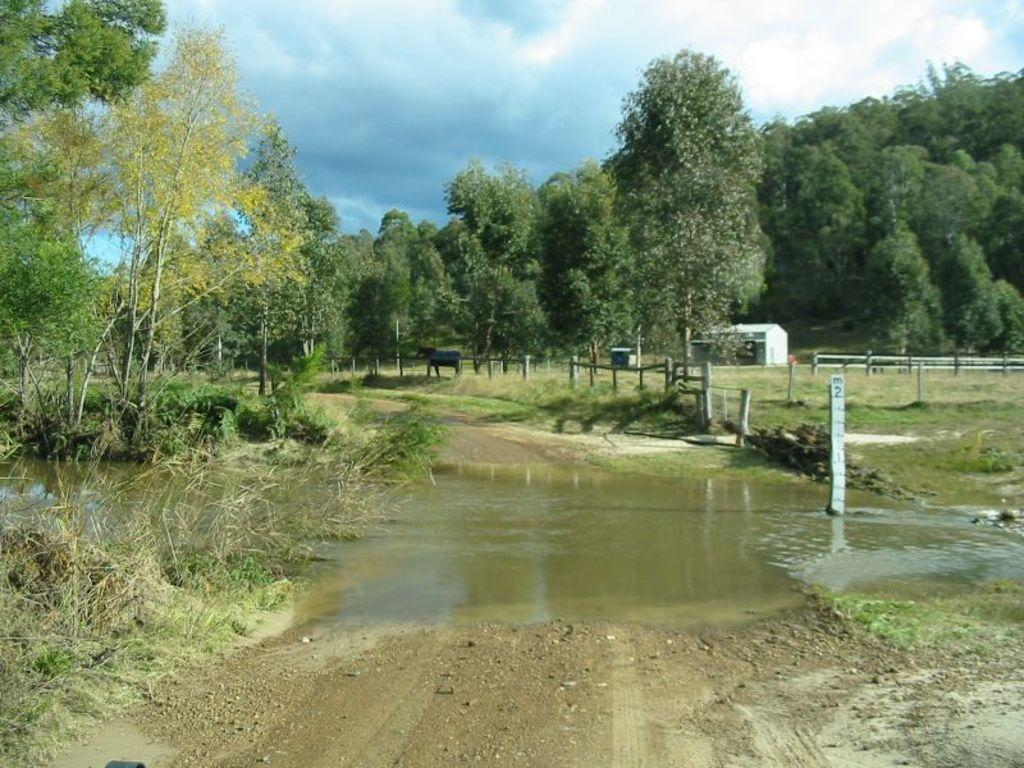What is happening in the foreground of the image? There is water flowing on the road in the foreground of the image. What can be seen in the background of the image? There are trees, an animal, a house, and a cloudy sky in the background of the image. What type of oatmeal is being measured in the image? There is no oatmeal or measuring activity present in the image. How hot is the water flowing on the road in the image? The temperature of the water flowing on the road is not mentioned in the image, so it cannot be determined. 